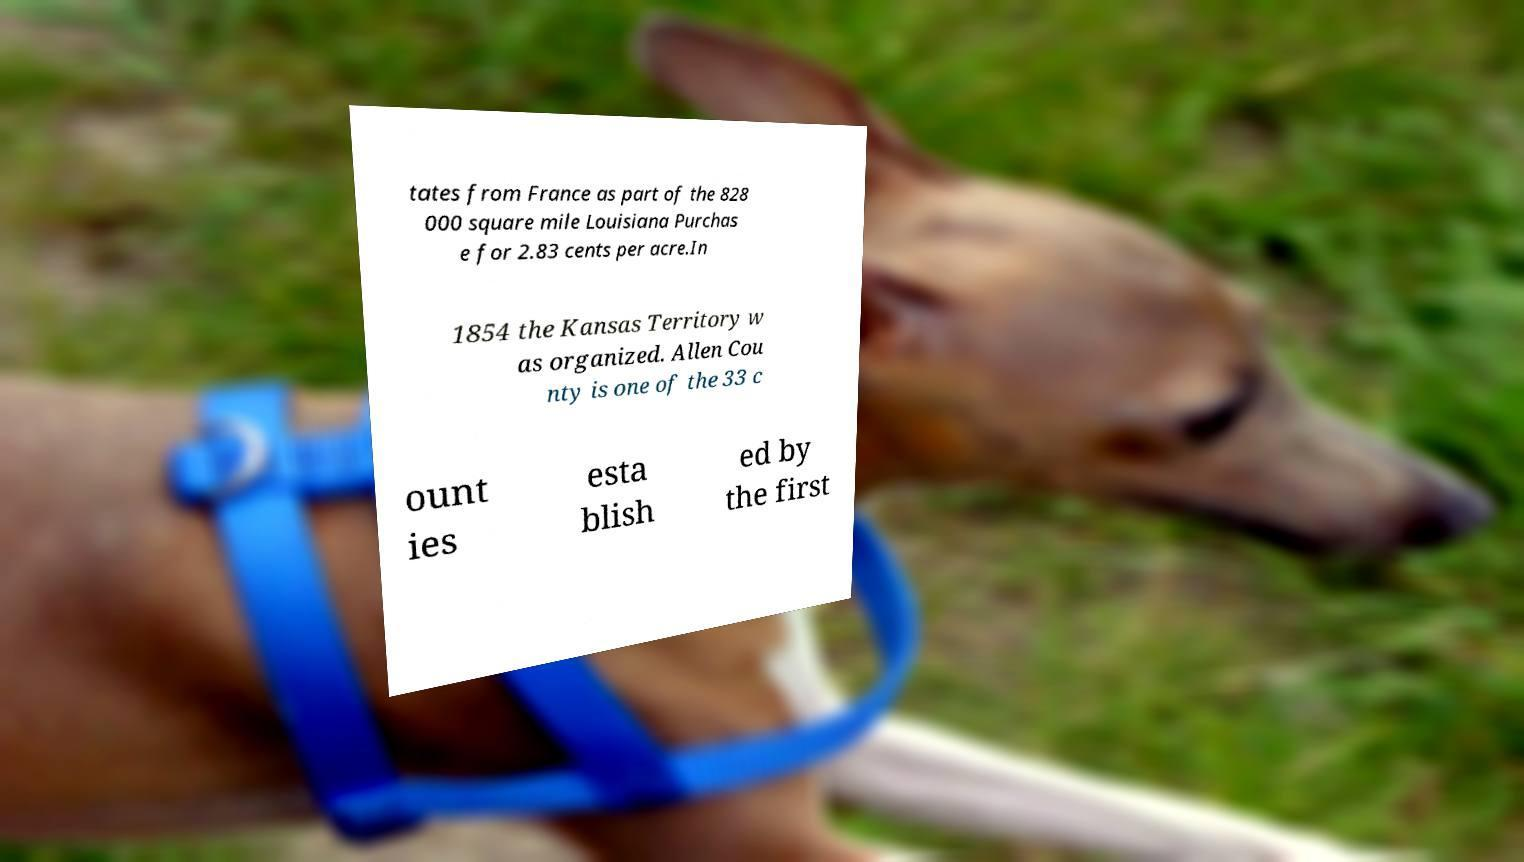Can you accurately transcribe the text from the provided image for me? tates from France as part of the 828 000 square mile Louisiana Purchas e for 2.83 cents per acre.In 1854 the Kansas Territory w as organized. Allen Cou nty is one of the 33 c ount ies esta blish ed by the first 